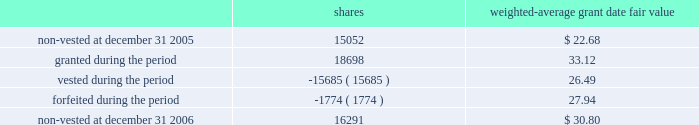O 2019 r e i l l y a u t o m o t i v e 2 0 0 6 a n n u a l r e p o r t p a g e 38 $ 11080000 , in the years ended december 31 , 2006 , 2005 and 2004 , respectively .
The remaining unrecognized compensation cost related to unvested awards at december 31 , 2006 , was $ 7702000 and the weighted-average period of time over which this cost will be recognized is 3.3 years .
Employee stock purchase plan the company 2019s employee stock purchase plan permits all eligible employees to purchase shares of the company 2019s common stock at 85% ( 85 % ) of the fair market value .
Participants may authorize the company to withhold up to 5% ( 5 % ) of their annual salary to participate in the plan .
The stock purchase plan authorizes up to 2600000 shares to be granted .
During the year ended december 31 , 2006 , the company issued 165306 shares under the purchase plan at a weighted average price of $ 27.36 per share .
During the year ended december 31 , 2005 , the company issued 161903 shares under the purchase plan at a weighted average price of $ 27.57 per share .
During the year ended december 31 , 2004 , the company issued 187754 shares under the purchase plan at a weighted average price of $ 20.85 per share .
Sfas no .
123r requires compensation expense to be recognized based on the discount between the grant date fair value and the employee purchase price for shares sold to employees .
During the year ended december 31 , 2006 , the company recorded $ 799000 of compensation cost related to employee share purchases and a corresponding income tax benefit of $ 295000 .
At december 31 , 2006 , approximately 400000 shares were reserved for future issuance .
Other employee benefit plans the company sponsors a contributory profit sharing and savings plan that covers substantially all employees who are at least 21 years of age and have at least six months of service .
The company has agreed to make matching contributions equal to 50% ( 50 % ) of the first 2% ( 2 % ) of each employee 2019s wages that are contributed and 25% ( 25 % ) of the next 4% ( 4 % ) of each employee 2019s wages that are contributed .
The company also makes additional discretionary profit sharing contributions to the plan on an annual basis as determined by the board of directors .
The company 2019s matching and profit sharing contributions under this plan are funded in the form of shares of the company 2019s common stock .
A total of 4200000 shares of common stock have been authorized for issuance under this plan .
During the year ended december 31 , 2006 , the company recorded $ 6429000 of compensation cost for contributions to this plan and a corresponding income tax benefit of $ 2372000 .
During the year ended december 31 , 2005 , the company recorded $ 6606000 of compensation cost for contributions to this plan and a corresponding income tax benefit of $ 2444000 .
During the year ended december 31 , 2004 , the company recorded $ 5278000 of compensation cost for contributions to this plan and a corresponding income tax benefit of $ 1969000 .
The compensation cost recorded in 2006 includes matching contributions made in 2006 and profit sharing contributions accrued in 2006 to be funded with issuance of shares of common stock in 2007 .
The company issued 204000 shares in 2006 to fund profit sharing and matching contributions at an average grant date fair value of $ 34.34 .
The company issued 210461 shares in 2005 to fund profit sharing and matching contributions at an average grant date fair value of $ 25.79 .
The company issued 238828 shares in 2004 to fund profit sharing and matching contributions at an average grant date fair value of $ 19.36 .
A portion of these shares related to profit sharing contributions accrued in prior periods .
At december 31 , 2006 , approximately 1061000 shares were reserved for future issuance under this plan .
The company has in effect a performance incentive plan for the company 2019s senior management under which the company awards shares of restricted stock that vest equally over a three-year period and are held in escrow until such vesting has occurred .
Shares are forfeited when an employee ceases employment .
A total of 800000 shares of common stock have been authorized for issuance under this plan .
Shares awarded under this plan are valued based on the market price of the company 2019s common stock on the date of grant and compensation cost is recorded over the vesting period .
The company recorded $ 416000 of compensation cost for this plan for the year ended december 31 , 2006 and recognized a corresponding income tax benefit of $ 154000 .
The company recorded $ 289000 of compensation cost for this plan for the year ended december 31 , 2005 and recognized a corresponding income tax benefit of $ 107000 .
The company recorded $ 248000 of compensation cost for this plan for the year ended december 31 , 2004 and recognized a corresponding income tax benefit of $ 93000 .
The total fair value of shares vested ( at vest date ) for the years ended december 31 , 2006 , 2005 and 2004 were $ 503000 , $ 524000 and $ 335000 , respectively .
The remaining unrecognized compensation cost related to unvested awards at december 31 , 2006 was $ 536000 .
The company awarded 18698 shares under this plan in 2006 with an average grant date fair value of $ 33.12 .
The company awarded 14986 shares under this plan in 2005 with an average grant date fair value of $ 25.41 .
The company awarded 15834 shares under this plan in 2004 with an average grant date fair value of $ 19.05 .
Compensation cost for shares awarded in 2006 will be recognized over the three-year vesting period .
Changes in the company 2019s restricted stock for the year ended december 31 , 2006 were as follows : weighted- average grant date shares fair value .
At december 31 , 2006 , approximately 659000 shares were reserved for future issuance under this plan .
N o t e s t o c o n s o l i d a t e d f i n a n c i a l s t a t e m e n t s ( cont inued ) .
What is the amount of cash raised from the issuance of shares during 2016 , in millions? 
Computations: ((165306 * 27.36) / 1000000)
Answer: 4.52277. 